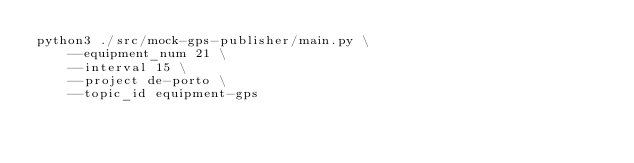<code> <loc_0><loc_0><loc_500><loc_500><_Bash_>python3 ./src/mock-gps-publisher/main.py \
    --equipment_num 21 \
    --interval 15 \
    --project de-porto \
    --topic_id equipment-gps</code> 